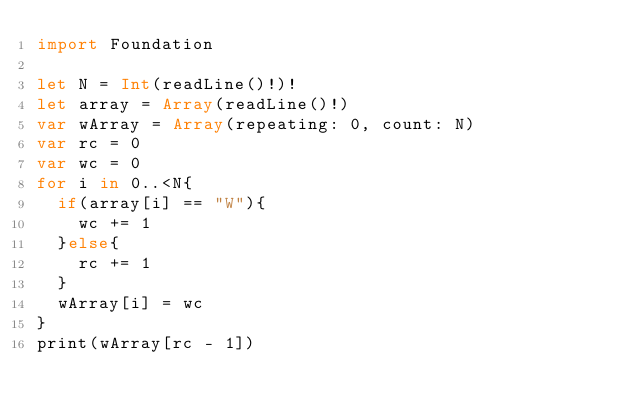<code> <loc_0><loc_0><loc_500><loc_500><_Swift_>import Foundation

let N = Int(readLine()!)!
let array = Array(readLine()!)
var wArray = Array(repeating: 0, count: N)
var rc = 0
var wc = 0
for i in 0..<N{
  if(array[i] == "W"){
    wc += 1
  }else{
    rc += 1
  }
  wArray[i] = wc
}
print(wArray[rc - 1])</code> 